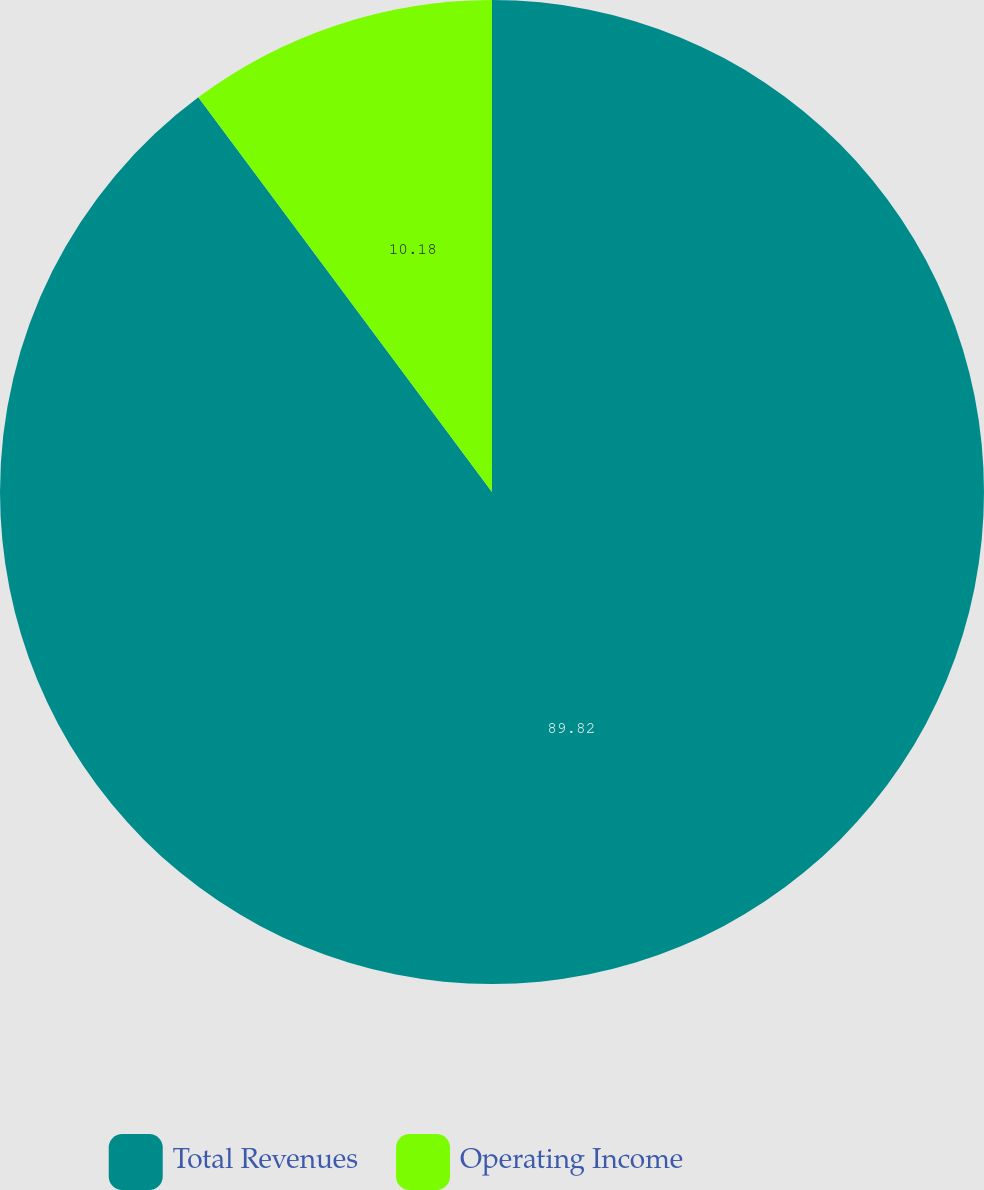Convert chart. <chart><loc_0><loc_0><loc_500><loc_500><pie_chart><fcel>Total Revenues<fcel>Operating Income<nl><fcel>89.82%<fcel>10.18%<nl></chart> 